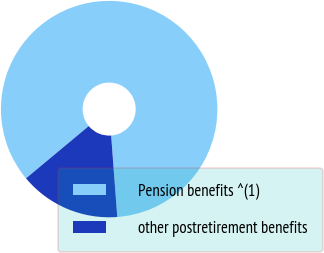Convert chart. <chart><loc_0><loc_0><loc_500><loc_500><pie_chart><fcel>Pension benefits ^(1)<fcel>other postretirement benefits<nl><fcel>84.86%<fcel>15.14%<nl></chart> 